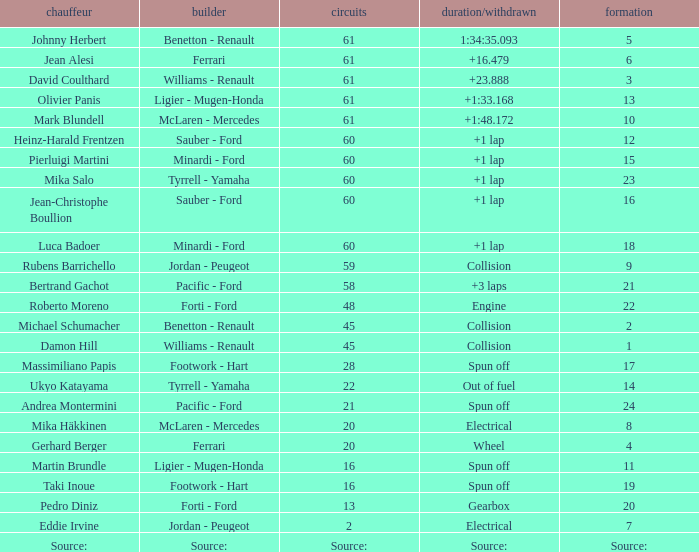What's the time/retired for a grid of 14? Out of fuel. Write the full table. {'header': ['chauffeur', 'builder', 'circuits', 'duration/withdrawn', 'formation'], 'rows': [['Johnny Herbert', 'Benetton - Renault', '61', '1:34:35.093', '5'], ['Jean Alesi', 'Ferrari', '61', '+16.479', '6'], ['David Coulthard', 'Williams - Renault', '61', '+23.888', '3'], ['Olivier Panis', 'Ligier - Mugen-Honda', '61', '+1:33.168', '13'], ['Mark Blundell', 'McLaren - Mercedes', '61', '+1:48.172', '10'], ['Heinz-Harald Frentzen', 'Sauber - Ford', '60', '+1 lap', '12'], ['Pierluigi Martini', 'Minardi - Ford', '60', '+1 lap', '15'], ['Mika Salo', 'Tyrrell - Yamaha', '60', '+1 lap', '23'], ['Jean-Christophe Boullion', 'Sauber - Ford', '60', '+1 lap', '16'], ['Luca Badoer', 'Minardi - Ford', '60', '+1 lap', '18'], ['Rubens Barrichello', 'Jordan - Peugeot', '59', 'Collision', '9'], ['Bertrand Gachot', 'Pacific - Ford', '58', '+3 laps', '21'], ['Roberto Moreno', 'Forti - Ford', '48', 'Engine', '22'], ['Michael Schumacher', 'Benetton - Renault', '45', 'Collision', '2'], ['Damon Hill', 'Williams - Renault', '45', 'Collision', '1'], ['Massimiliano Papis', 'Footwork - Hart', '28', 'Spun off', '17'], ['Ukyo Katayama', 'Tyrrell - Yamaha', '22', 'Out of fuel', '14'], ['Andrea Montermini', 'Pacific - Ford', '21', 'Spun off', '24'], ['Mika Häkkinen', 'McLaren - Mercedes', '20', 'Electrical', '8'], ['Gerhard Berger', 'Ferrari', '20', 'Wheel', '4'], ['Martin Brundle', 'Ligier - Mugen-Honda', '16', 'Spun off', '11'], ['Taki Inoue', 'Footwork - Hart', '16', 'Spun off', '19'], ['Pedro Diniz', 'Forti - Ford', '13', 'Gearbox', '20'], ['Eddie Irvine', 'Jordan - Peugeot', '2', 'Electrical', '7'], ['Source:', 'Source:', 'Source:', 'Source:', 'Source:']]} 